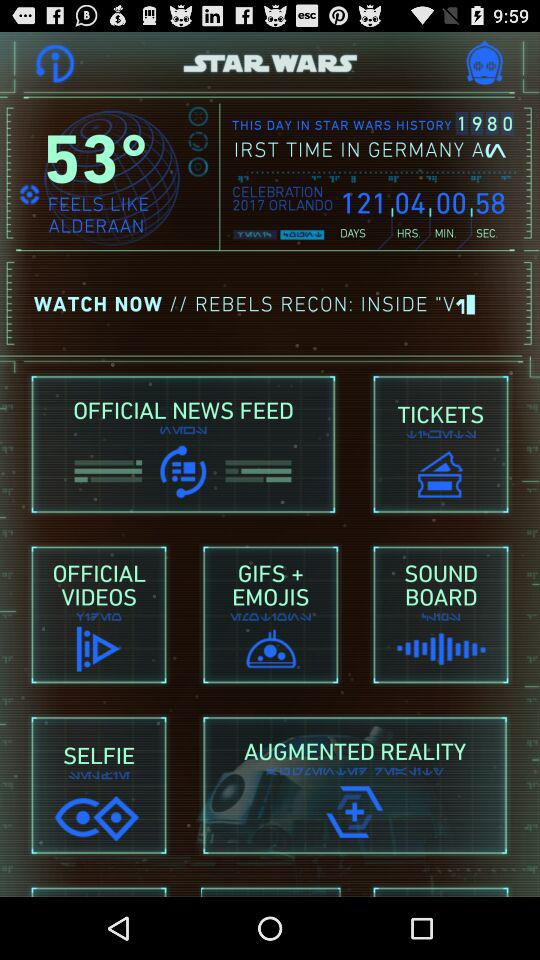How many more days are left until the next celebration?
Answer the question using a single word or phrase. 121 days 